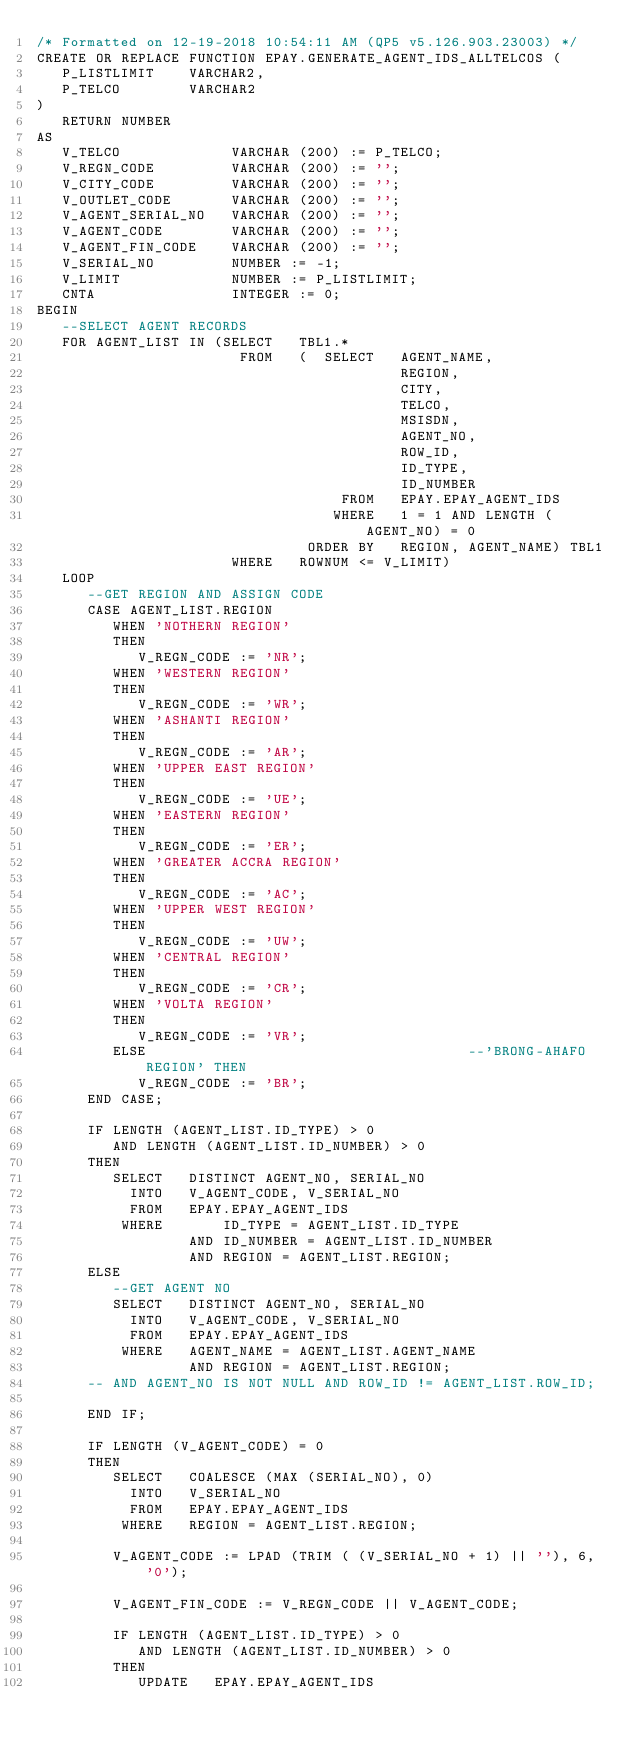Convert code to text. <code><loc_0><loc_0><loc_500><loc_500><_SQL_>/* Formatted on 12-19-2018 10:54:11 AM (QP5 v5.126.903.23003) */
CREATE OR REPLACE FUNCTION EPAY.GENERATE_AGENT_IDS_ALLTELCOS (
   P_LISTLIMIT    VARCHAR2,
   P_TELCO        VARCHAR2
)
   RETURN NUMBER
AS
   V_TELCO             VARCHAR (200) := P_TELCO;
   V_REGN_CODE         VARCHAR (200) := '';
   V_CITY_CODE         VARCHAR (200) := '';
   V_OUTLET_CODE       VARCHAR (200) := '';
   V_AGENT_SERIAL_NO   VARCHAR (200) := '';
   V_AGENT_CODE        VARCHAR (200) := '';
   V_AGENT_FIN_CODE    VARCHAR (200) := '';
   V_SERIAL_NO         NUMBER := -1;
   V_LIMIT             NUMBER := P_LISTLIMIT;
   CNTA                INTEGER := 0;
BEGIN
   --SELECT AGENT RECORDS
   FOR AGENT_LIST IN (SELECT   TBL1.*
                        FROM   (  SELECT   AGENT_NAME,
                                           REGION,
                                           CITY,
                                           TELCO,
                                           MSISDN,
                                           AGENT_NO,
                                           ROW_ID,
                                           ID_TYPE,
                                           ID_NUMBER
                                    FROM   EPAY.EPAY_AGENT_IDS
                                   WHERE   1 = 1 AND LENGTH (AGENT_NO) = 0
                                ORDER BY   REGION, AGENT_NAME) TBL1
                       WHERE   ROWNUM <= V_LIMIT)
   LOOP
      --GET REGION AND ASSIGN CODE
      CASE AGENT_LIST.REGION
         WHEN 'NOTHERN REGION'
         THEN
            V_REGN_CODE := 'NR';
         WHEN 'WESTERN REGION'
         THEN
            V_REGN_CODE := 'WR';
         WHEN 'ASHANTI REGION'
         THEN
            V_REGN_CODE := 'AR';
         WHEN 'UPPER EAST REGION'
         THEN
            V_REGN_CODE := 'UE';
         WHEN 'EASTERN REGION'
         THEN
            V_REGN_CODE := 'ER';
         WHEN 'GREATER ACCRA REGION'
         THEN
            V_REGN_CODE := 'AC';
         WHEN 'UPPER WEST REGION'
         THEN
            V_REGN_CODE := 'UW';
         WHEN 'CENTRAL REGION'
         THEN
            V_REGN_CODE := 'CR';
         WHEN 'VOLTA REGION'
         THEN
            V_REGN_CODE := 'VR';
         ELSE                                      --'BRONG-AHAFO REGION' THEN
            V_REGN_CODE := 'BR';
      END CASE;

      IF LENGTH (AGENT_LIST.ID_TYPE) > 0
         AND LENGTH (AGENT_LIST.ID_NUMBER) > 0
      THEN
         SELECT   DISTINCT AGENT_NO, SERIAL_NO
           INTO   V_AGENT_CODE, V_SERIAL_NO
           FROM   EPAY.EPAY_AGENT_IDS
          WHERE       ID_TYPE = AGENT_LIST.ID_TYPE
                  AND ID_NUMBER = AGENT_LIST.ID_NUMBER
                  AND REGION = AGENT_LIST.REGION;
      ELSE
         --GET AGENT NO
         SELECT   DISTINCT AGENT_NO, SERIAL_NO
           INTO   V_AGENT_CODE, V_SERIAL_NO
           FROM   EPAY.EPAY_AGENT_IDS
          WHERE   AGENT_NAME = AGENT_LIST.AGENT_NAME
                  AND REGION = AGENT_LIST.REGION;
      -- AND AGENT_NO IS NOT NULL AND ROW_ID != AGENT_LIST.ROW_ID;

      END IF;

      IF LENGTH (V_AGENT_CODE) = 0
      THEN
         SELECT   COALESCE (MAX (SERIAL_NO), 0)
           INTO   V_SERIAL_NO
           FROM   EPAY.EPAY_AGENT_IDS
          WHERE   REGION = AGENT_LIST.REGION;

         V_AGENT_CODE := LPAD (TRIM ( (V_SERIAL_NO + 1) || ''), 6, '0');

         V_AGENT_FIN_CODE := V_REGN_CODE || V_AGENT_CODE;

         IF LENGTH (AGENT_LIST.ID_TYPE) > 0
            AND LENGTH (AGENT_LIST.ID_NUMBER) > 0
         THEN
            UPDATE   EPAY.EPAY_AGENT_IDS</code> 